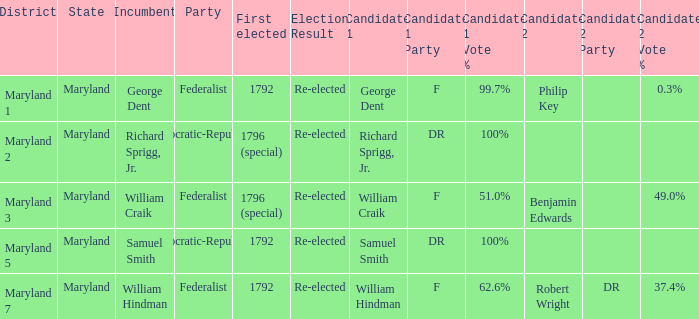What is the district for the party federalist and the candidates are william craik (f) 51.0% benjamin edwards 49.0%? Maryland 3. 